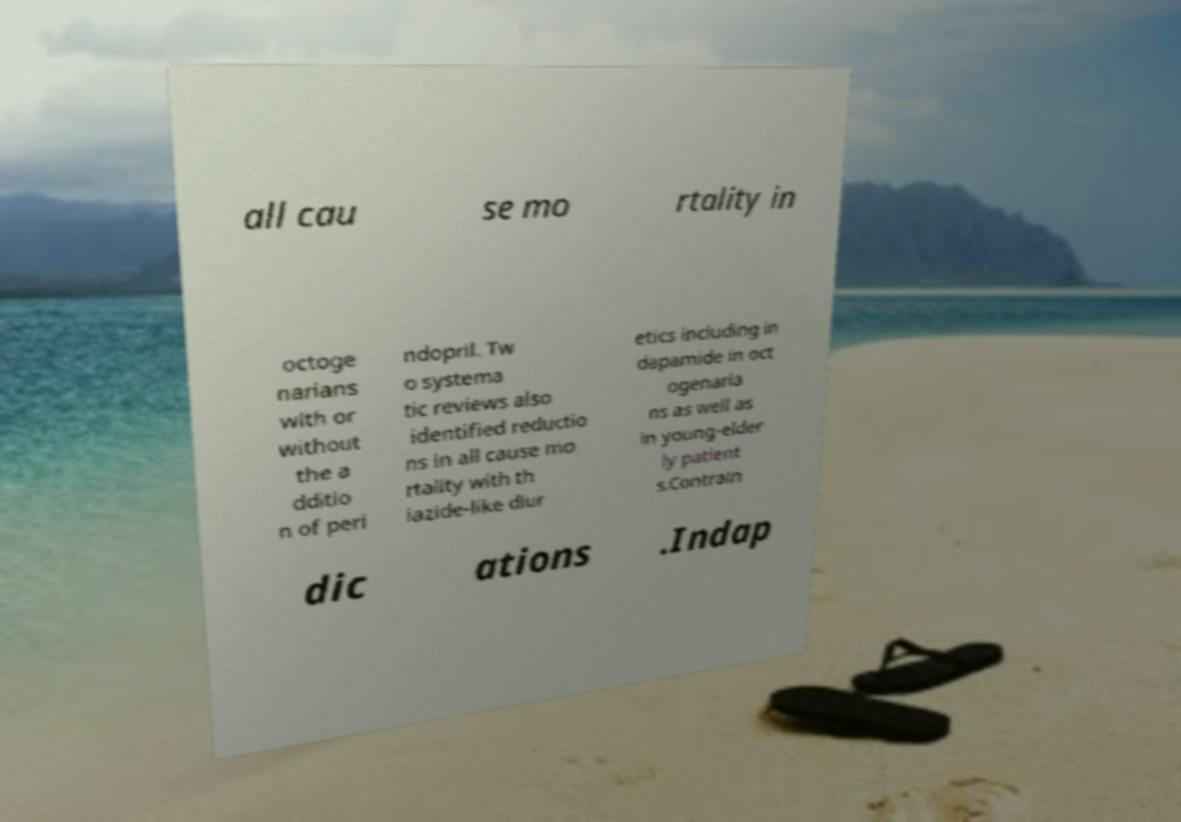For documentation purposes, I need the text within this image transcribed. Could you provide that? all cau se mo rtality in octoge narians with or without the a dditio n of peri ndopril. Tw o systema tic reviews also identified reductio ns in all cause mo rtality with th iazide-like diur etics including in dapamide in oct ogenaria ns as well as in young-elder ly patient s.Contrain dic ations .Indap 